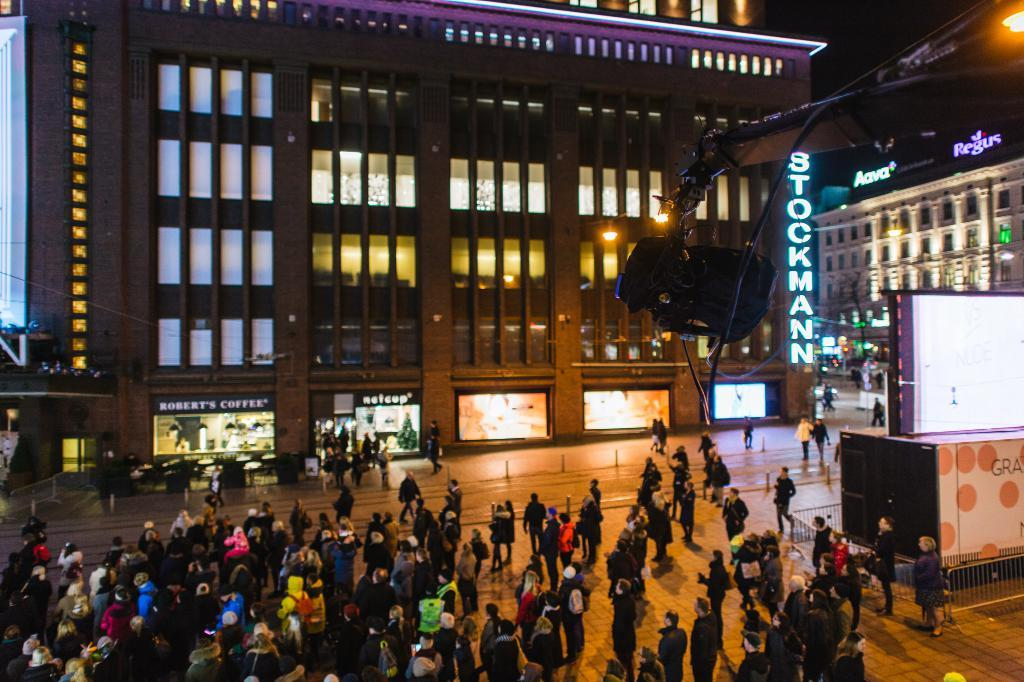<image>
Present a compact description of the photo's key features. people gathered outside building that has a robert's coffee and netcup in it and a large stockman sign on the side 